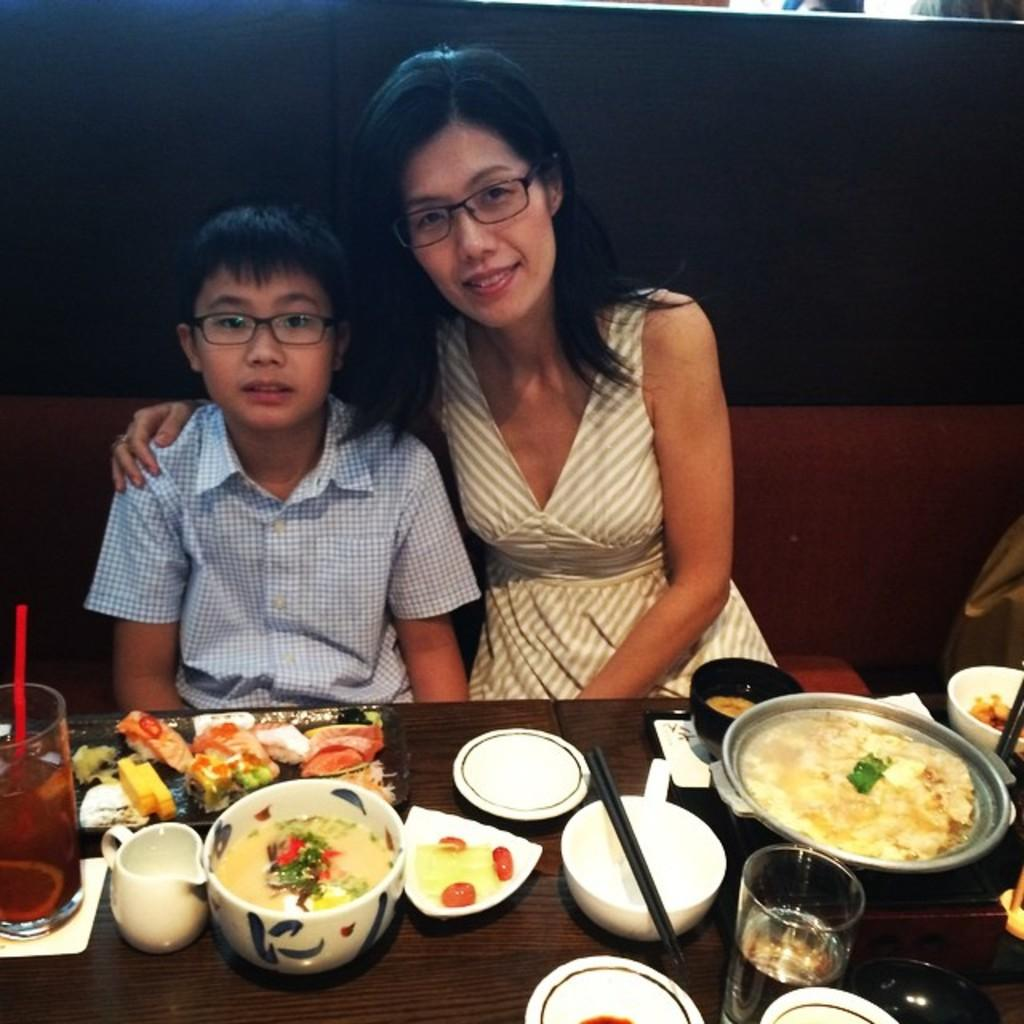How many people are in the image? There are two people in the image. What are the people doing in the image? The people are sitting on a couch. What is in front of the couch? There is a table in front of the couch. What can be found on the table? Food items are placed on the table. What book is the person reading in the image? There is no book present in the image; the people are sitting on a couch and there are food items on the table. 